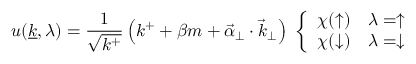Convert formula to latex. <formula><loc_0><loc_0><loc_500><loc_500>u ( { \underline { k } } , \lambda ) = { \frac { 1 } { \sqrt { k ^ { + } } } } \left ( k ^ { + } + \beta m + { \vec { \alpha } } _ { \perp } \cdot { \vec { k } } _ { \perp } \right ) \ \left \{ \begin{array} { l l } { \chi ( \uparrow ) } & { \lambda = \uparrow } \\ { \chi ( \downarrow ) } & { \lambda = \downarrow } \end{array}</formula> 